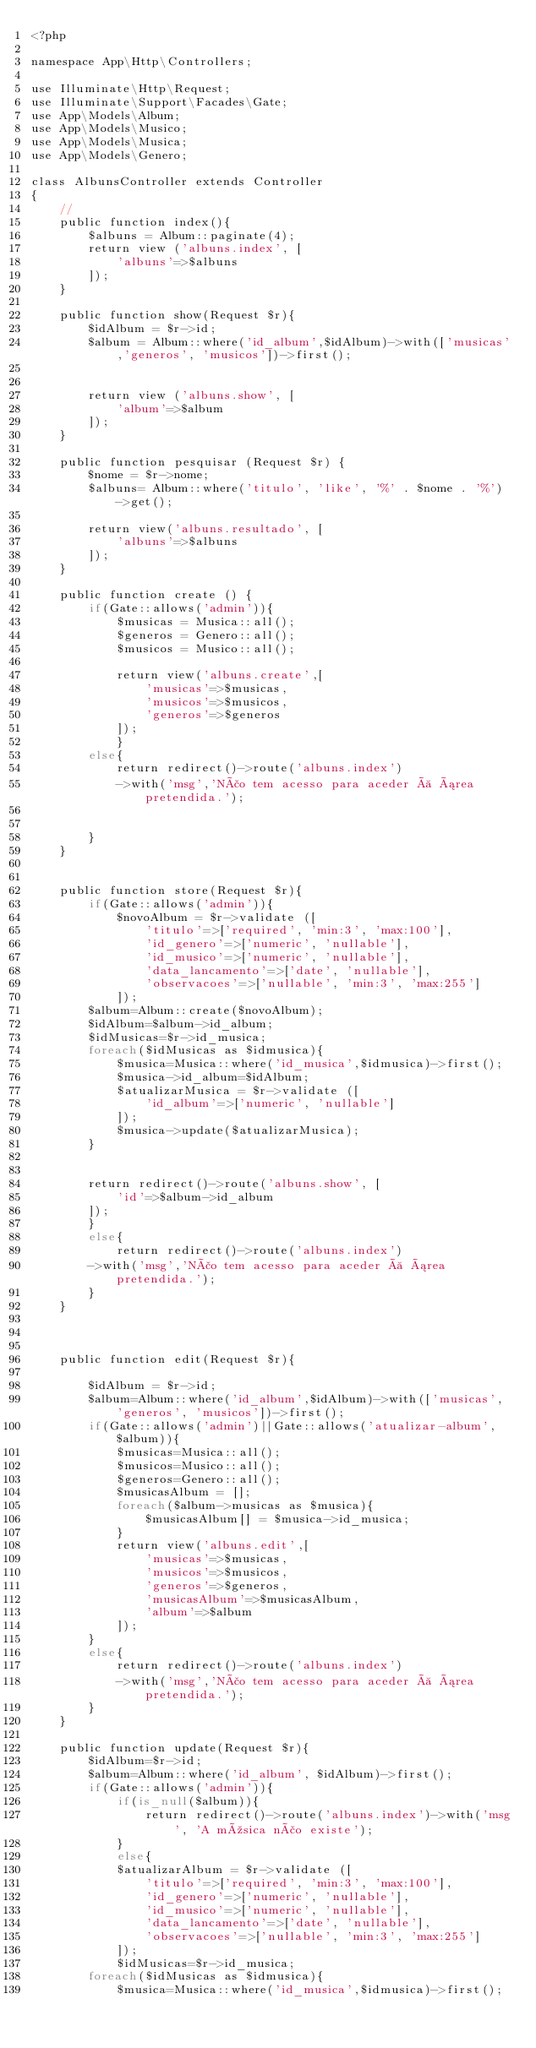Convert code to text. <code><loc_0><loc_0><loc_500><loc_500><_PHP_><?php

namespace App\Http\Controllers;

use Illuminate\Http\Request;
use Illuminate\Support\Facades\Gate;
use App\Models\Album;
use App\Models\Musico;
use App\Models\Musica;
use App\Models\Genero;

class AlbunsController extends Controller
{
    //
    public function index(){
        $albuns = Album::paginate(4);
        return view ('albuns.index', [
            'albuns'=>$albuns
        ]);
    }
    
    public function show(Request $r){
        $idAlbum = $r->id;
        $album = Album::where('id_album',$idAlbum)->with(['musicas','generos', 'musicos'])->first();
    
        
        return view ('albuns.show', [
            'album'=>$album
        ]);
    }
    
    public function pesquisar (Request $r) {
        $nome = $r->nome;
        $albuns= Album::where('titulo', 'like', '%' . $nome . '%')->get();
        
        return view('albuns.resultado', [
            'albuns'=>$albuns
        ]);
    }

    public function create () {
        if(Gate::allows('admin')){
            $musicas = Musica::all();
            $generos = Genero::all();
            $musicos = Musico::all();

            return view('albuns.create',[
                'musicas'=>$musicas,
                'musicos'=>$musicos,
                'generos'=>$generos
            ]);
            }
        else{
            return redirect()->route('albuns.index')
            ->with('msg','Não tem acesso para aceder à área pretendida.');
        
        
        }
    }


    public function store(Request $r){
        if(Gate::allows('admin')){
            $novoAlbum = $r->validate ([
                'titulo'=>['required', 'min:3', 'max:100'],
                'id_genero'=>['numeric', 'nullable'],
                'id_musico'=>['numeric', 'nullable'],
                'data_lancamento'=>['date', 'nullable'],
                'observacoes'=>['nullable', 'min:3', 'max:255']
            ]);
        $album=Album::create($novoAlbum);
        $idAlbum=$album->id_album;
        $idMusicas=$r->id_musica;
        foreach($idMusicas as $idmusica){
            $musica=Musica::where('id_musica',$idmusica)->first();  
            $musica->id_album=$idAlbum;
            $atualizarMusica = $r->validate ([
                'id_album'=>['numeric', 'nullable']
            ]);
            $musica->update($atualizarMusica);
        }


        return redirect()->route('albuns.show', [
            'id'=>$album->id_album
        ]);
        }
        else{
            return redirect()->route('albuns.index')
        ->with('msg','Não tem acesso para aceder à área pretendida.');
        }
    }



    public function edit(Request $r){
        
        $idAlbum = $r->id;
        $album=Album::where('id_album',$idAlbum)->with(['musicas', 'generos', 'musicos'])->first();
        if(Gate::allows('admin')||Gate::allows('atualizar-album',$album)){
            $musicas=Musica::all();
            $musicos=Musico::all();
            $generos=Genero::all();
            $musicasAlbum = [];
            foreach($album->musicas as $musica){
                $musicasAlbum[] = $musica->id_musica;
            }
            return view('albuns.edit',[
                'musicas'=>$musicas,
                'musicos'=>$musicos,
                'generos'=>$generos,
                'musicasAlbum'=>$musicasAlbum,  
                'album'=>$album
            ]);
        }
        else{
            return redirect()->route('albuns.index')
            ->with('msg','Não tem acesso para aceder à área pretendida.');
        }
    }

    public function update(Request $r){
        $idAlbum=$r->id;
        $album=Album::where('id_album', $idAlbum)->first();
        if(Gate::allows('admin')){
            if(is_null($album)){
                return redirect()->route('albuns.index')->with('msg', 'A música não existe');
            }
            else{
            $atualizarAlbum = $r->validate ([
                'titulo'=>['required', 'min:3', 'max:100'],
                'id_genero'=>['numeric', 'nullable'],
                'id_musico'=>['numeric', 'nullable'],
                'data_lancamento'=>['date', 'nullable'],
                'observacoes'=>['nullable', 'min:3', 'max:255']
            ]);
            $idMusicas=$r->id_musica;
        foreach($idMusicas as $idmusica){
            $musica=Musica::where('id_musica',$idmusica)->first();  </code> 